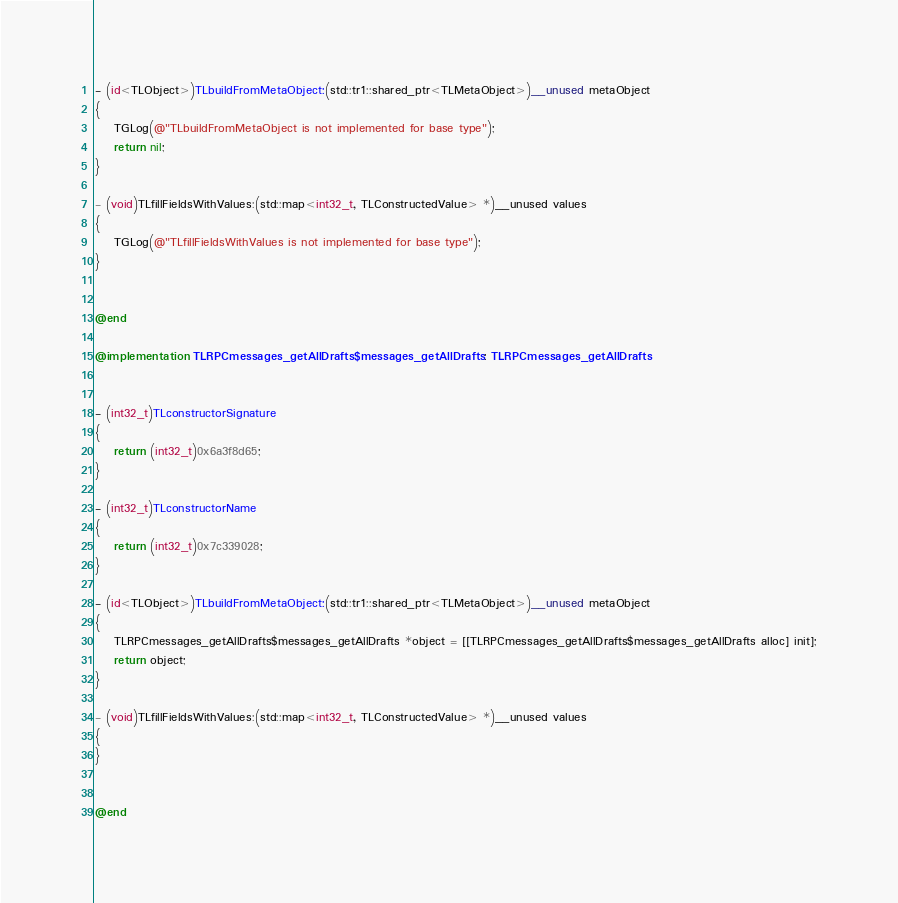<code> <loc_0><loc_0><loc_500><loc_500><_ObjectiveC_>- (id<TLObject>)TLbuildFromMetaObject:(std::tr1::shared_ptr<TLMetaObject>)__unused metaObject
{
    TGLog(@"TLbuildFromMetaObject is not implemented for base type");
    return nil;
}

- (void)TLfillFieldsWithValues:(std::map<int32_t, TLConstructedValue> *)__unused values
{
    TGLog(@"TLfillFieldsWithValues is not implemented for base type");
}


@end

@implementation TLRPCmessages_getAllDrafts$messages_getAllDrafts : TLRPCmessages_getAllDrafts


- (int32_t)TLconstructorSignature
{
    return (int32_t)0x6a3f8d65;
}

- (int32_t)TLconstructorName
{
    return (int32_t)0x7c339028;
}

- (id<TLObject>)TLbuildFromMetaObject:(std::tr1::shared_ptr<TLMetaObject>)__unused metaObject
{
    TLRPCmessages_getAllDrafts$messages_getAllDrafts *object = [[TLRPCmessages_getAllDrafts$messages_getAllDrafts alloc] init];
    return object;
}

- (void)TLfillFieldsWithValues:(std::map<int32_t, TLConstructedValue> *)__unused values
{
}


@end

</code> 